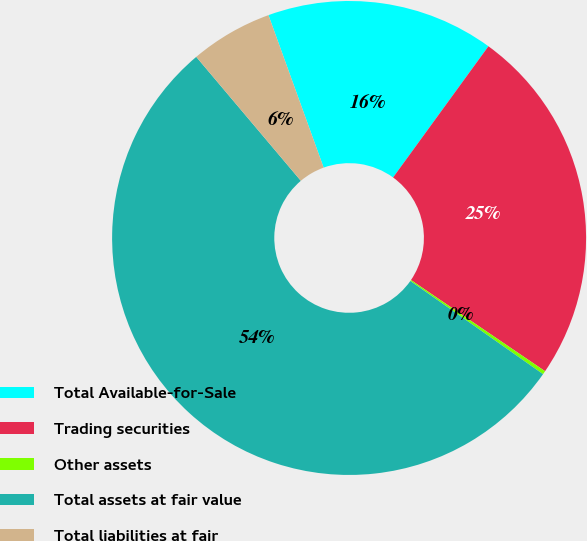Convert chart. <chart><loc_0><loc_0><loc_500><loc_500><pie_chart><fcel>Total Available-for-Sale<fcel>Trading securities<fcel>Other assets<fcel>Total assets at fair value<fcel>Total liabilities at fair<nl><fcel>15.53%<fcel>24.5%<fcel>0.24%<fcel>54.1%<fcel>5.63%<nl></chart> 